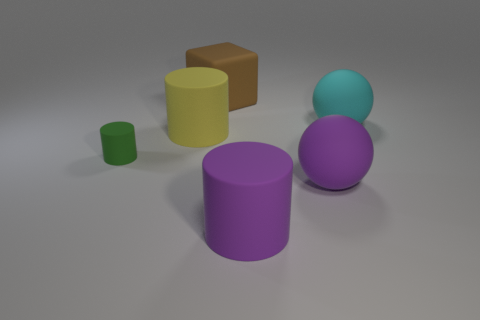Add 1 large gray things. How many objects exist? 7 Subtract all blocks. How many objects are left? 5 Add 1 small rubber things. How many small rubber things are left? 2 Add 5 yellow metallic things. How many yellow metallic things exist? 5 Subtract 1 green cylinders. How many objects are left? 5 Subtract all small metal cylinders. Subtract all cyan objects. How many objects are left? 5 